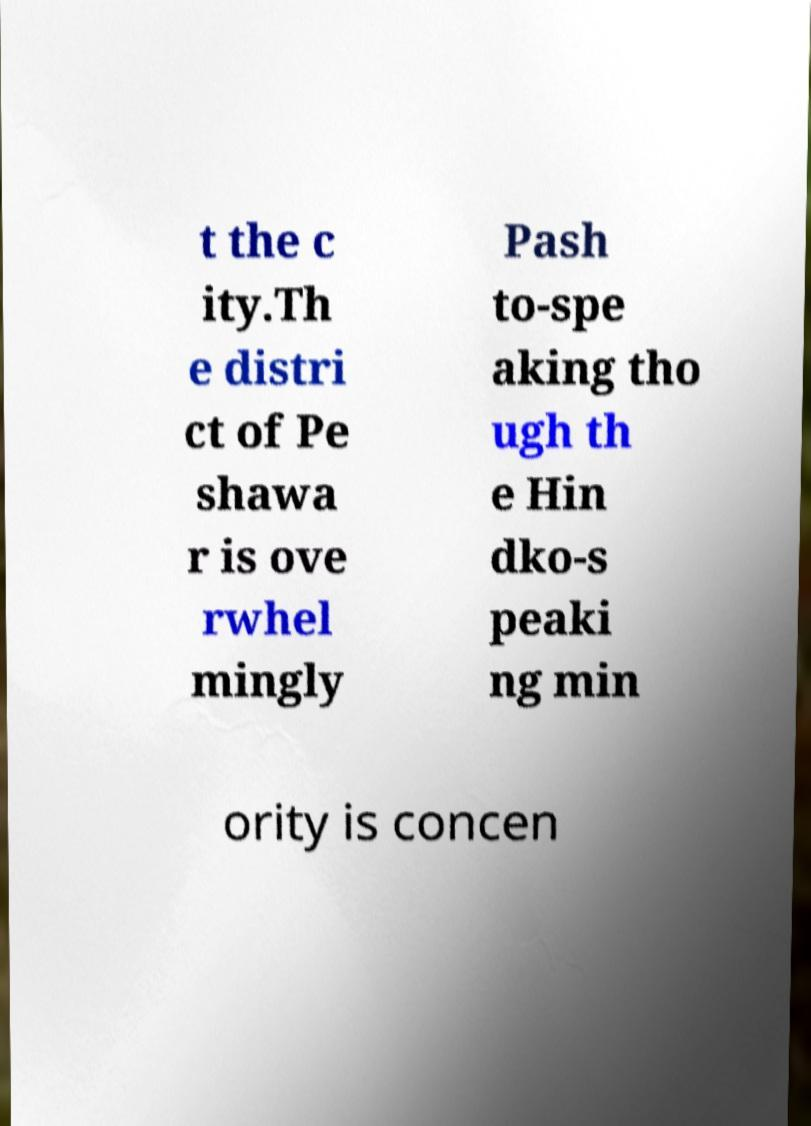There's text embedded in this image that I need extracted. Can you transcribe it verbatim? t the c ity.Th e distri ct of Pe shawa r is ove rwhel mingly Pash to-spe aking tho ugh th e Hin dko-s peaki ng min ority is concen 